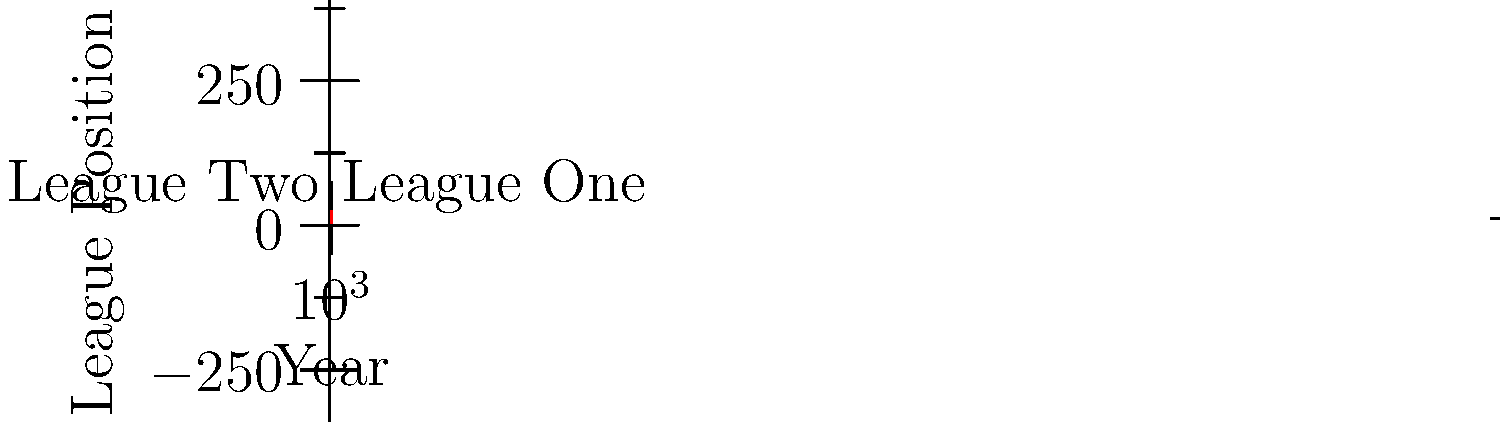Based on the line graph showing Bradford City's league positions from 2010 to 2020, in which year did the club achieve its highest league position during this period? To determine the year when Bradford City achieved its highest league position, we need to follow these steps:

1. Understand that in football league tables, a lower number indicates a higher position (e.g., 1st is higher than 5th).
2. Scan the graph from left to right, looking for the lowest point on the line.
3. We can see that the line dips to its lowest point twice, in 2015 and 2016.
4. Both of these points correspond to a 5th place finish, which is the highest (lowest number) on the graph.
5. Since the question asks for a single year, we'll choose the first occurrence of this highest position.

Therefore, Bradford City achieved its highest league position in 2015, finishing 5th.
Answer: 2015 